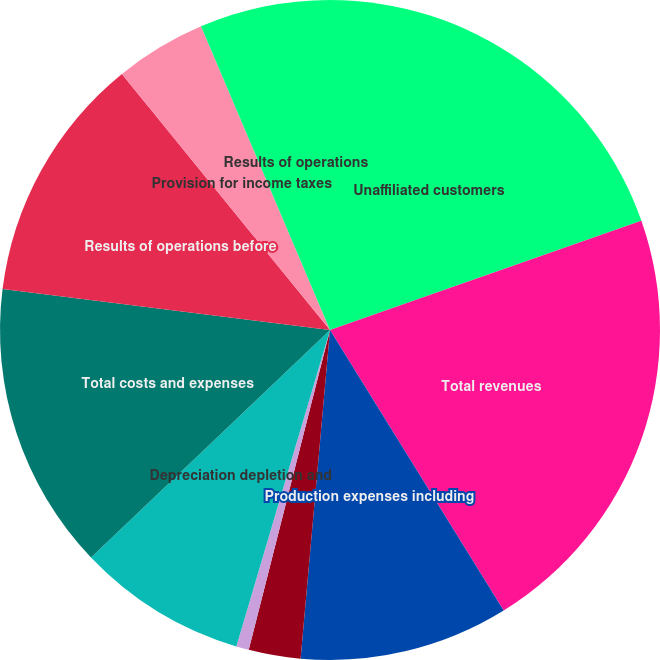Convert chart. <chart><loc_0><loc_0><loc_500><loc_500><pie_chart><fcel>Unaffiliated customers<fcel>Total revenues<fcel>Production expenses including<fcel>Exploration expenses including<fcel>General administrative and<fcel>Depreciation depletion and<fcel>Total costs and expenses<fcel>Results of operations before<fcel>Provision for income taxes<fcel>Results of operations<nl><fcel>19.63%<fcel>21.55%<fcel>10.24%<fcel>2.54%<fcel>0.62%<fcel>8.31%<fcel>14.09%<fcel>12.16%<fcel>4.47%<fcel>6.39%<nl></chart> 